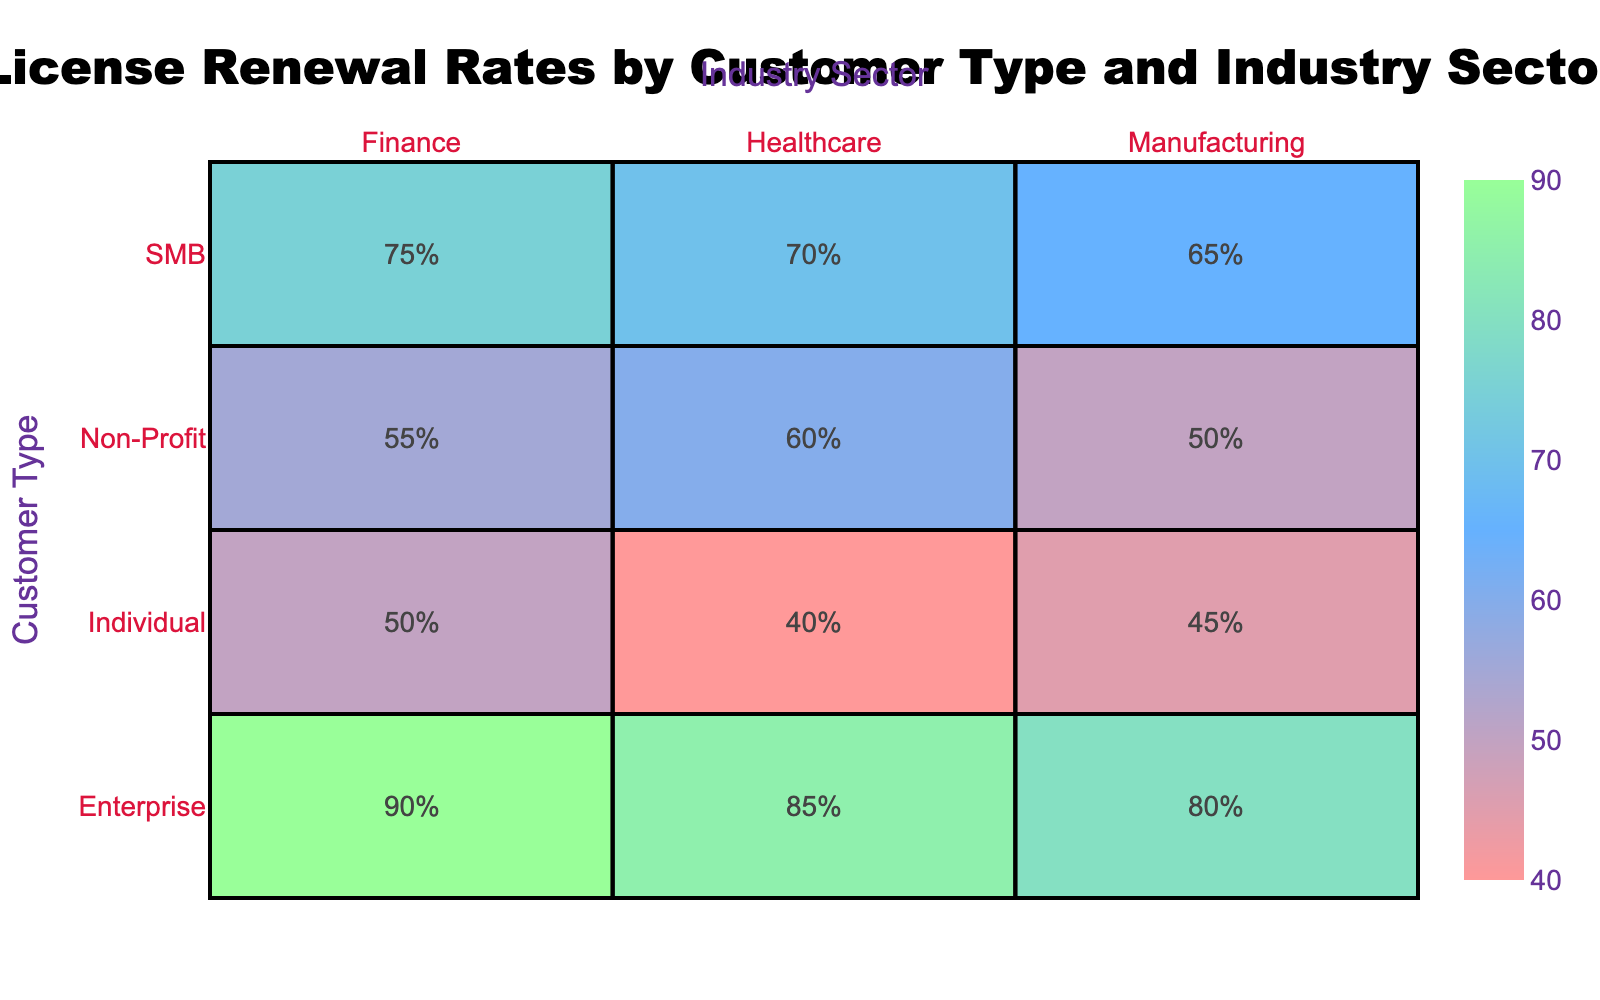What is the license renewal rate for Enterprises in the Finance sector? From the table, by looking at the row for Enterprises and the column for Finance, the renewal rate is 90.
Answer: 90 What is the license renewal rate for Individuals in the Healthcare sector? Checking the row for Individuals and the column for Healthcare, the renewal rate is 40.
Answer: 40 Which customer type has the highest license renewal rate in the Manufacturing sector? In the Manufacturing sector, the rates are 80 for Enterprises, 65 for SMBs, 45 for Individuals, and 50 for Non-Profits. The highest is 80 for Enterprises.
Answer: Enterprises What is the average license renewal rate for SMBs across all sectors? The renewal rates for SMBs are 70 (Healthcare), 75 (Finance), and 65 (Manufacturing). Adding these gives 70 + 75 + 65 = 210. There are 3 sectors, so the average is 210/3 = 70.
Answer: 70 Does the Individual customer type have an equal renewal rate across all industry sectors? The renewal rates for Individuals are 40 (Healthcare), 50 (Finance), and 45 (Manufacturing). Since these are different, the rates are not equal.
Answer: No What is the difference in license renewal rates between Non-Profits in Healthcare and Enterprises in the same sector? The renewal rate for Non-Profits in Healthcare is 60, while for Enterprises it is 85. The difference is 85 - 60 = 25.
Answer: 25 Which industry sector shows the lowest renewal rate for SMBs? Looking at the SMB row across sectors, the rates are 70 for Healthcare, 75 for Finance, and 65 for Manufacturing. The lowest is 65 for Manufacturing.
Answer: Manufacturing If we combine the license renewal rates for all Industries under Non-Profits, what is the total? The Non-Profit renewal rates are 60 (Healthcare) + 55 (Finance) + 50 (Manufacturing) = 165.
Answer: 165 In which customer type and industry combination do we see the highest license renewal rate? By scanning the table, the highest rate is 90, found in the combination of Enterprises and Finance.
Answer: Enterprises in Finance 